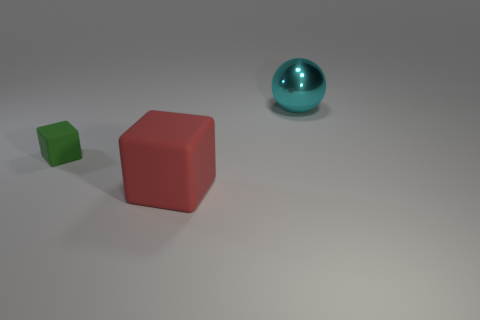There is a matte object behind the big red rubber object; is its shape the same as the red matte object?
Keep it short and to the point. Yes. Is there anything else of the same color as the small rubber object?
Make the answer very short. No. What is the size of the red thing that is the same material as the green block?
Offer a very short reply. Large. There is a big object that is on the left side of the big object to the right of the large thing that is to the left of the cyan shiny ball; what is it made of?
Ensure brevity in your answer.  Rubber. Are there fewer small cubes than rubber objects?
Provide a short and direct response. Yes. Does the cyan ball have the same material as the small green cube?
Offer a terse response. No. There is a object that is to the left of the red object; does it have the same color as the large sphere?
Make the answer very short. No. How many red rubber objects are behind the big thing that is behind the tiny green object?
Make the answer very short. 0. What color is the rubber thing that is the same size as the metal thing?
Provide a short and direct response. Red. There is a object in front of the small rubber cube; what material is it?
Your response must be concise. Rubber. 